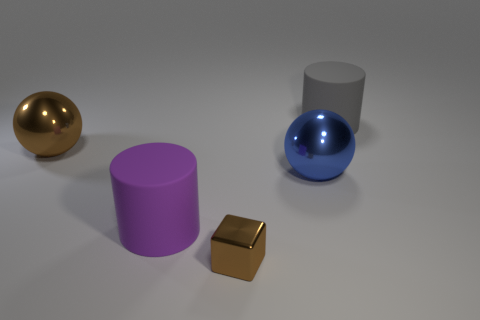Is there anything else that is the same size as the metal block?
Offer a very short reply. No. There is a brown thing that is behind the ball on the right side of the purple cylinder; how many large brown balls are right of it?
Offer a very short reply. 0. How many other things are there of the same material as the blue object?
Your answer should be compact. 2. There is a gray thing that is the same size as the blue metal ball; what is its material?
Offer a very short reply. Rubber. Is the color of the metallic object that is in front of the purple rubber thing the same as the large sphere left of the tiny brown object?
Make the answer very short. Yes. Are there any gray objects of the same shape as the big purple thing?
Provide a succinct answer. Yes. What is the shape of the brown object that is the same size as the blue thing?
Keep it short and to the point. Sphere. How many matte cylinders have the same color as the tiny object?
Your response must be concise. 0. There is a cylinder that is in front of the big blue metallic object; how big is it?
Offer a terse response. Large. What number of metallic objects are the same size as the purple matte object?
Give a very brief answer. 2. 